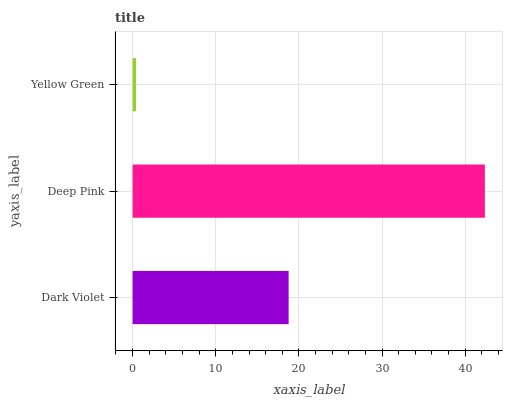Is Yellow Green the minimum?
Answer yes or no. Yes. Is Deep Pink the maximum?
Answer yes or no. Yes. Is Deep Pink the minimum?
Answer yes or no. No. Is Yellow Green the maximum?
Answer yes or no. No. Is Deep Pink greater than Yellow Green?
Answer yes or no. Yes. Is Yellow Green less than Deep Pink?
Answer yes or no. Yes. Is Yellow Green greater than Deep Pink?
Answer yes or no. No. Is Deep Pink less than Yellow Green?
Answer yes or no. No. Is Dark Violet the high median?
Answer yes or no. Yes. Is Dark Violet the low median?
Answer yes or no. Yes. Is Yellow Green the high median?
Answer yes or no. No. Is Yellow Green the low median?
Answer yes or no. No. 